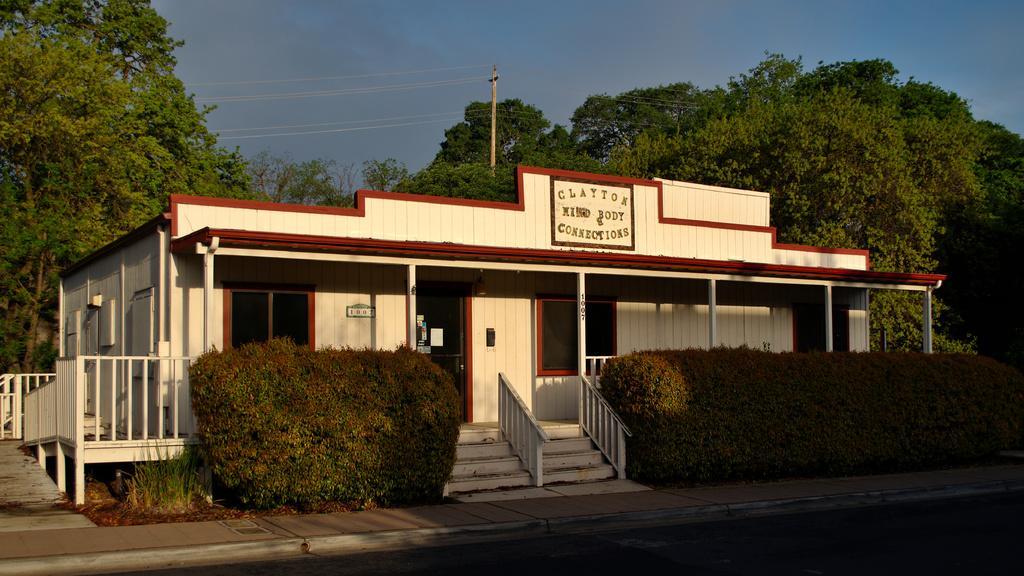Could you give a brief overview of what you see in this image? This image is taken outdoors. At the bottom of the image there is a road and a sidewalk. At the top of the image there is a sky. In the background there are a few trees. In the middle of the image there is a house with a few walls, windows and a door and there is a board with a text on it. There is a railing and a few stairs. There are a few plants. 